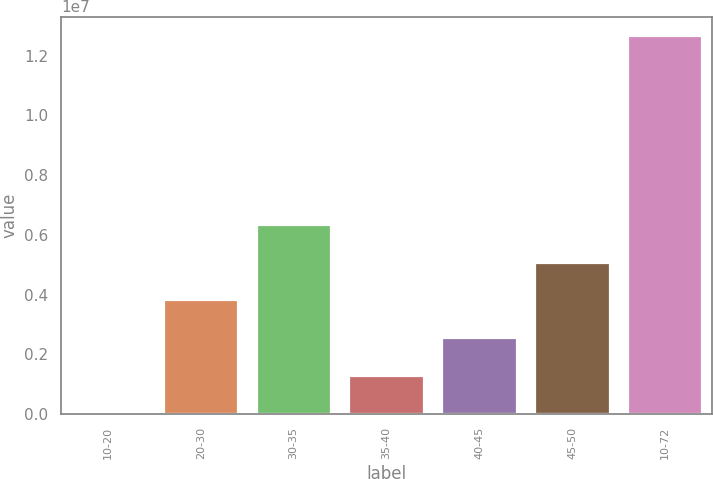Convert chart to OTSL. <chart><loc_0><loc_0><loc_500><loc_500><bar_chart><fcel>10-20<fcel>20-30<fcel>30-35<fcel>35-40<fcel>40-45<fcel>45-50<fcel>10-72<nl><fcel>3797<fcel>3.80394e+06<fcel>6.33737e+06<fcel>1.27051e+06<fcel>2.53723e+06<fcel>5.07066e+06<fcel>1.26709e+07<nl></chart> 